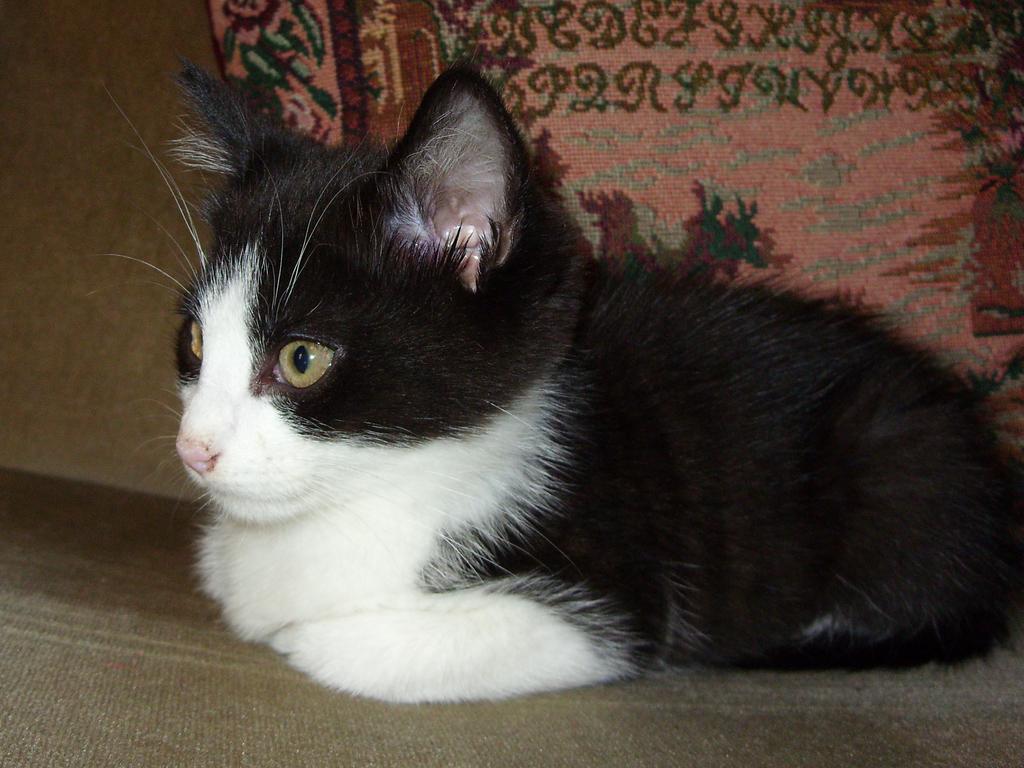Can you describe this image briefly? In this image there is one black and white color cat as we can see in middle of this image, and there is a pillow on the top of this image. 